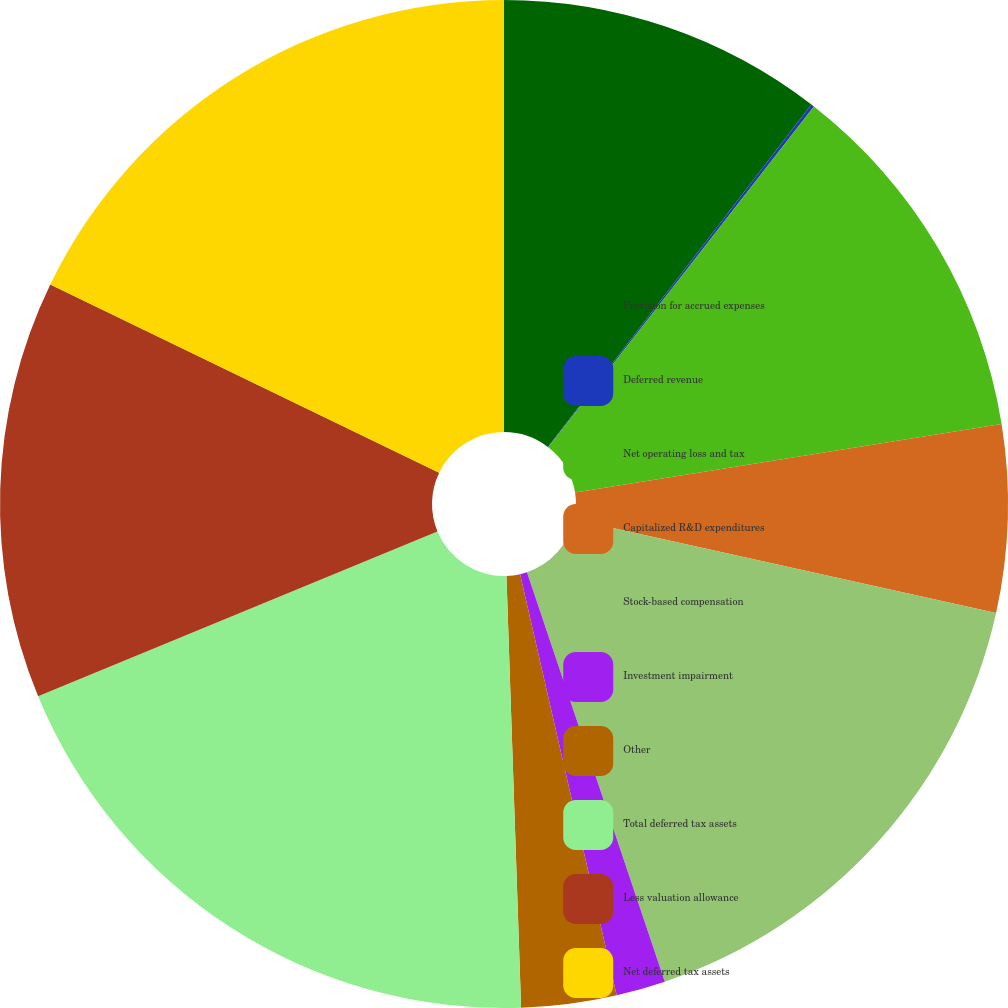Convert chart to OTSL. <chart><loc_0><loc_0><loc_500><loc_500><pie_chart><fcel>Provision for accrued expenses<fcel>Deferred revenue<fcel>Net operating loss and tax<fcel>Capitalized R&D expenditures<fcel>Stock-based compensation<fcel>Investment impairment<fcel>Other<fcel>Total deferred tax assets<fcel>Less valuation allowance<fcel>Net deferred tax assets<nl><fcel>10.44%<fcel>0.1%<fcel>11.92%<fcel>6.01%<fcel>16.36%<fcel>1.58%<fcel>3.05%<fcel>19.31%<fcel>13.4%<fcel>17.83%<nl></chart> 